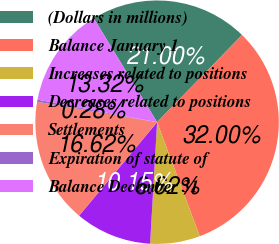Convert chart. <chart><loc_0><loc_0><loc_500><loc_500><pie_chart><fcel>(Dollars in millions)<fcel>Balance January 1<fcel>Increases related to positions<fcel>Decreases related to positions<fcel>Settlements<fcel>Expiration of statute of<fcel>Balance December 31<nl><fcel>21.0%<fcel>32.0%<fcel>6.62%<fcel>10.15%<fcel>16.62%<fcel>0.28%<fcel>13.32%<nl></chart> 